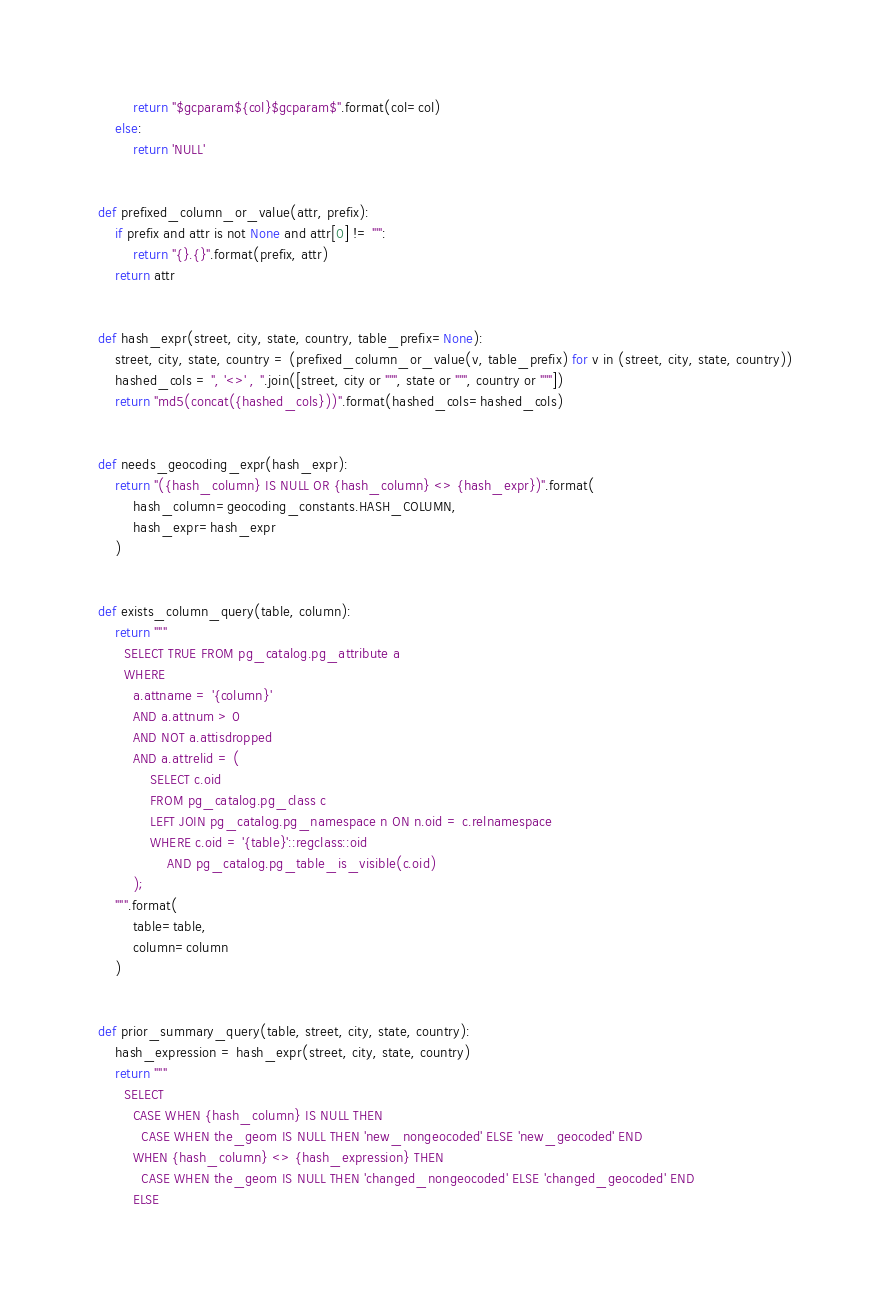<code> <loc_0><loc_0><loc_500><loc_500><_Python_>        return "$gcparam${col}$gcparam$".format(col=col)
    else:
        return 'NULL'


def prefixed_column_or_value(attr, prefix):
    if prefix and attr is not None and attr[0] != "'":
        return "{}.{}".format(prefix, attr)
    return attr


def hash_expr(street, city, state, country, table_prefix=None):
    street, city, state, country = (prefixed_column_or_value(v, table_prefix) for v in (street, city, state, country))
    hashed_cols = ", '<>' , ".join([street, city or "''", state or "''", country or "''"])
    return "md5(concat({hashed_cols}))".format(hashed_cols=hashed_cols)


def needs_geocoding_expr(hash_expr):
    return "({hash_column} IS NULL OR {hash_column} <> {hash_expr})".format(
        hash_column=geocoding_constants.HASH_COLUMN,
        hash_expr=hash_expr
    )


def exists_column_query(table, column):
    return """
      SELECT TRUE FROM pg_catalog.pg_attribute a
      WHERE
        a.attname = '{column}'
        AND a.attnum > 0
        AND NOT a.attisdropped
        AND a.attrelid = (
            SELECT c.oid
            FROM pg_catalog.pg_class c
            LEFT JOIN pg_catalog.pg_namespace n ON n.oid = c.relnamespace
            WHERE c.oid = '{table}'::regclass::oid
                AND pg_catalog.pg_table_is_visible(c.oid)
        );
    """.format(
        table=table,
        column=column
    )


def prior_summary_query(table, street, city, state, country):
    hash_expression = hash_expr(street, city, state, country)
    return """
      SELECT
        CASE WHEN {hash_column} IS NULL THEN
          CASE WHEN the_geom IS NULL THEN 'new_nongeocoded' ELSE 'new_geocoded' END
        WHEN {hash_column} <> {hash_expression} THEN
          CASE WHEN the_geom IS NULL THEN 'changed_nongeocoded' ELSE 'changed_geocoded' END
        ELSE</code> 